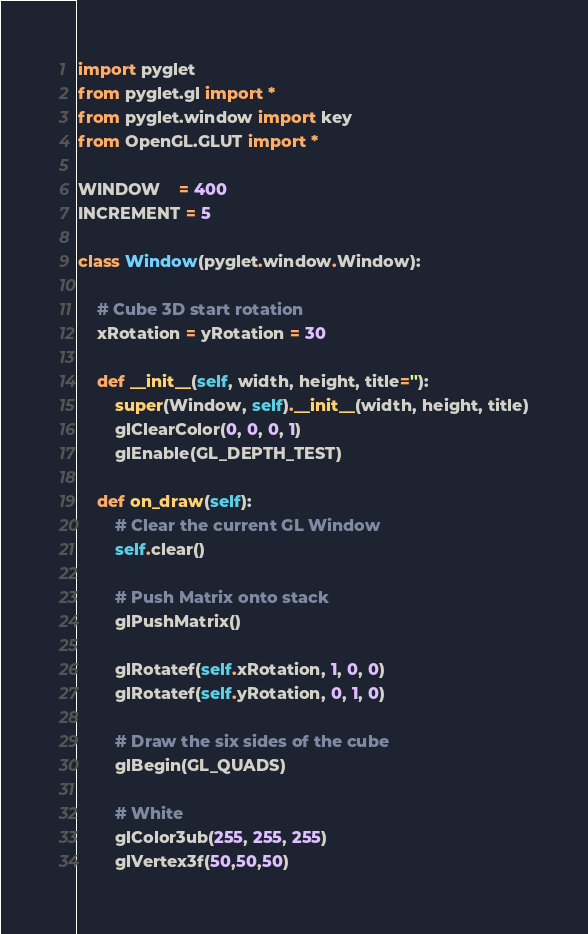<code> <loc_0><loc_0><loc_500><loc_500><_Python_>import pyglet
from pyglet.gl import *
from pyglet.window import key
from OpenGL.GLUT import *

WINDOW    = 400
INCREMENT = 5

class Window(pyglet.window.Window):

    # Cube 3D start rotation
    xRotation = yRotation = 30    

    def __init__(self, width, height, title=''):
        super(Window, self).__init__(width, height, title)
        glClearColor(0, 0, 0, 1)
        glEnable(GL_DEPTH_TEST)    

    def on_draw(self):
        # Clear the current GL Window
        self.clear()
        
        # Push Matrix onto stack
        glPushMatrix()

        glRotatef(self.xRotation, 1, 0, 0)
        glRotatef(self.yRotation, 0, 1, 0)

        # Draw the six sides of the cube
        glBegin(GL_QUADS)
        
        # White
        glColor3ub(255, 255, 255)
        glVertex3f(50,50,50)
</code> 